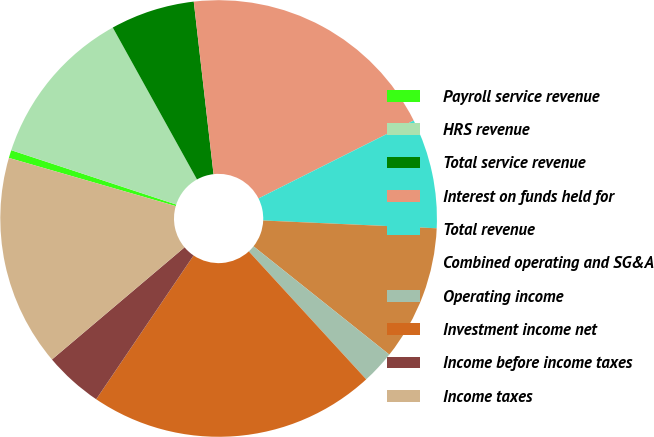Convert chart. <chart><loc_0><loc_0><loc_500><loc_500><pie_chart><fcel>Payroll service revenue<fcel>HRS revenue<fcel>Total service revenue<fcel>Interest on funds held for<fcel>Total revenue<fcel>Combined operating and SG&A<fcel>Operating income<fcel>Investment income net<fcel>Income before income taxes<fcel>Income taxes<nl><fcel>0.59%<fcel>11.88%<fcel>6.24%<fcel>19.41%<fcel>8.12%<fcel>10.0%<fcel>2.47%<fcel>21.29%<fcel>4.35%<fcel>15.65%<nl></chart> 